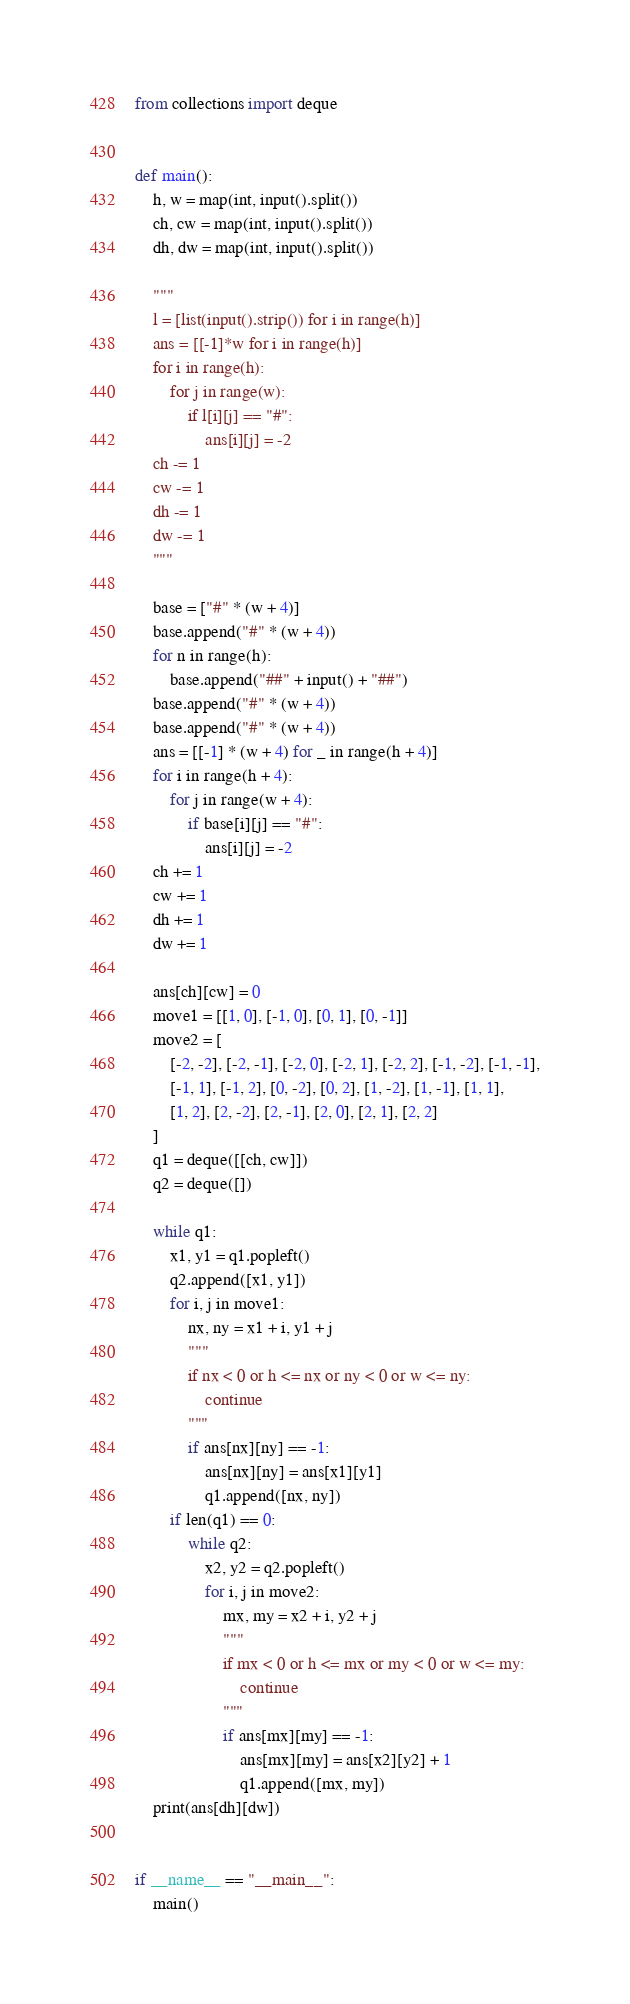Convert code to text. <code><loc_0><loc_0><loc_500><loc_500><_Python_>
from collections import deque


def main():
    h, w = map(int, input().split())
    ch, cw = map(int, input().split())
    dh, dw = map(int, input().split())

    """
    l = [list(input().strip()) for i in range(h)]
    ans = [[-1]*w for i in range(h)]
    for i in range(h):
        for j in range(w):
            if l[i][j] == "#":
                ans[i][j] = -2
    ch -= 1
    cw -= 1
    dh -= 1
    dw -= 1
    """

    base = ["#" * (w + 4)]
    base.append("#" * (w + 4))
    for n in range(h):
        base.append("##" + input() + "##")
    base.append("#" * (w + 4))
    base.append("#" * (w + 4))
    ans = [[-1] * (w + 4) for _ in range(h + 4)]
    for i in range(h + 4):
        for j in range(w + 4):
            if base[i][j] == "#":
                ans[i][j] = -2
    ch += 1
    cw += 1
    dh += 1
    dw += 1

    ans[ch][cw] = 0
    move1 = [[1, 0], [-1, 0], [0, 1], [0, -1]]
    move2 = [
        [-2, -2], [-2, -1], [-2, 0], [-2, 1], [-2, 2], [-1, -2], [-1, -1],
        [-1, 1], [-1, 2], [0, -2], [0, 2], [1, -2], [1, -1], [1, 1],
        [1, 2], [2, -2], [2, -1], [2, 0], [2, 1], [2, 2]
    ]
    q1 = deque([[ch, cw]])
    q2 = deque([])

    while q1:
        x1, y1 = q1.popleft()
        q2.append([x1, y1])
        for i, j in move1:
            nx, ny = x1 + i, y1 + j
            """
            if nx < 0 or h <= nx or ny < 0 or w <= ny:
                continue
            """
            if ans[nx][ny] == -1:
                ans[nx][ny] = ans[x1][y1]
                q1.append([nx, ny])
        if len(q1) == 0:
            while q2:
                x2, y2 = q2.popleft()
                for i, j in move2:
                    mx, my = x2 + i, y2 + j
                    """
                    if mx < 0 or h <= mx or my < 0 or w <= my:
                        continue
                    """
                    if ans[mx][my] == -1:
                        ans[mx][my] = ans[x2][y2] + 1
                        q1.append([mx, my])
    print(ans[dh][dw])


if __name__ == "__main__":
    main()


</code> 